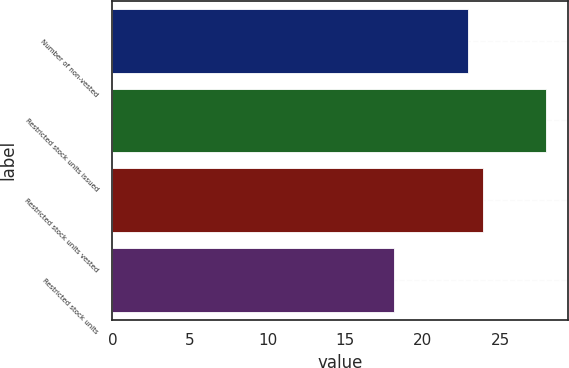Convert chart. <chart><loc_0><loc_0><loc_500><loc_500><bar_chart><fcel>Number of non-vested<fcel>Restricted stock units issued<fcel>Restricted stock units vested<fcel>Restricted stock units<nl><fcel>22.92<fcel>27.94<fcel>23.9<fcel>18.17<nl></chart> 